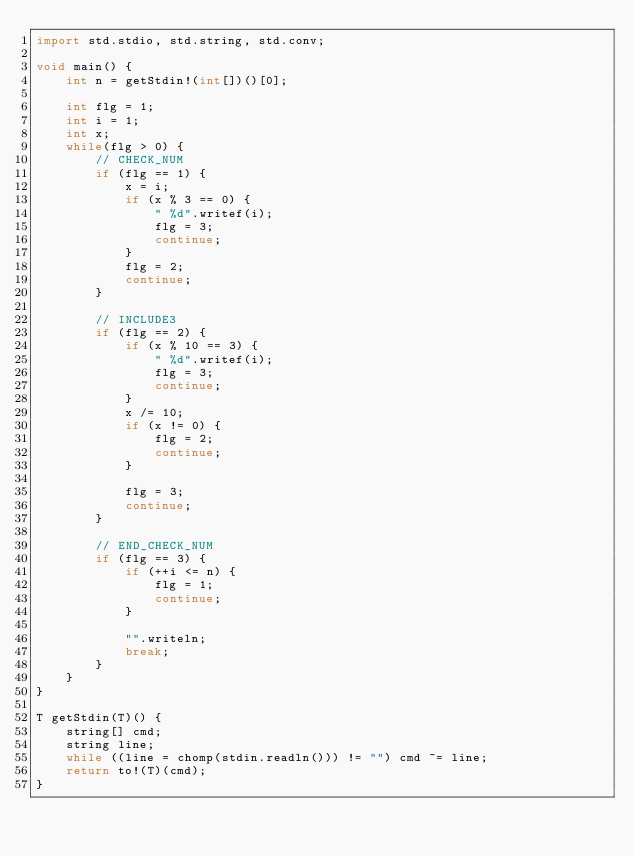<code> <loc_0><loc_0><loc_500><loc_500><_D_>import std.stdio, std.string, std.conv;

void main() {
    int n = getStdin!(int[])()[0];
    
    int flg = 1;
    int i = 1;
    int x;
    while(flg > 0) {
        // CHECK_NUM
        if (flg == 1) {
            x = i;
            if (x % 3 == 0) {
                " %d".writef(i);
                flg = 3;
                continue;
            }
            flg = 2;
            continue;
    	}

        // INCLUDE3
        if (flg == 2) {
            if (x % 10 == 3) {
                " %d".writef(i);
                flg = 3;
                continue;
            }
            x /= 10;
            if (x != 0) {
                flg = 2;
                continue;
            }

            flg = 3;
            continue;
        }

        // END_CHECK_NUM
        if (flg == 3) {
            if (++i <= n) {
                flg = 1;
                continue;
            }

            "".writeln;
            break;
        }
    }
}

T getStdin(T)() {
    string[] cmd;
    string line;
    while ((line = chomp(stdin.readln())) != "") cmd ~= line;
    return to!(T)(cmd);
}</code> 